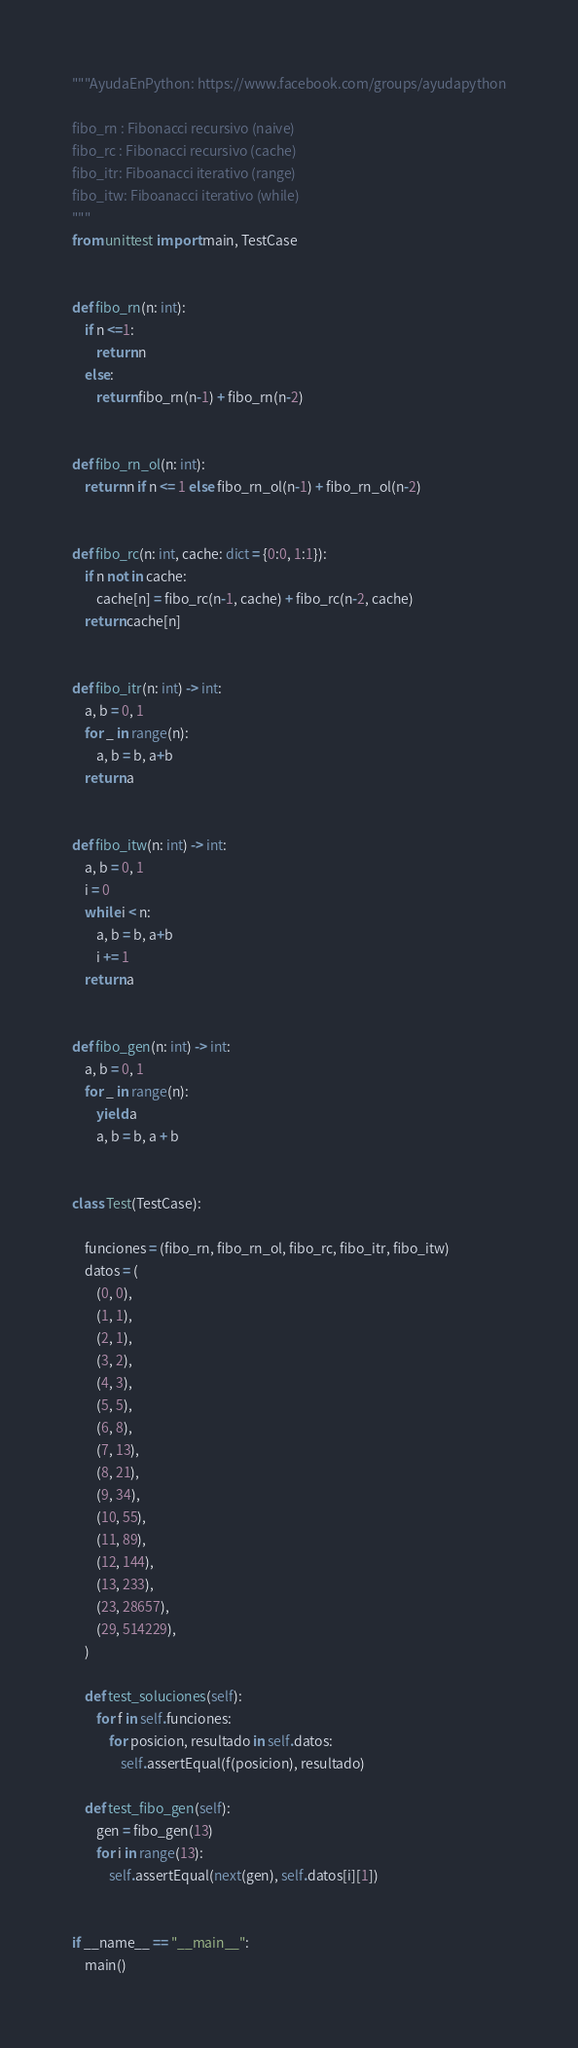<code> <loc_0><loc_0><loc_500><loc_500><_Python_>"""AyudaEnPython: https://www.facebook.com/groups/ayudapython

fibo_rn : Fibonacci recursivo (naive)
fibo_rc : Fibonacci recursivo (cache)
fibo_itr: Fiboanacci iterativo (range)
fibo_itw: Fiboanacci iterativo (while)
"""
from unittest import main, TestCase


def fibo_rn(n: int):
    if n <=1:
        return n
    else:
        return fibo_rn(n-1) + fibo_rn(n-2)


def fibo_rn_ol(n: int):
    return n if n <= 1 else fibo_rn_ol(n-1) + fibo_rn_ol(n-2)


def fibo_rc(n: int, cache: dict = {0:0, 1:1}):
    if n not in cache:
        cache[n] = fibo_rc(n-1, cache) + fibo_rc(n-2, cache)
    return cache[n]


def fibo_itr(n: int) -> int:
    a, b = 0, 1
    for _ in range(n):
        a, b = b, a+b
    return a


def fibo_itw(n: int) -> int:
    a, b = 0, 1
    i = 0
    while i < n:
        a, b = b, a+b
        i += 1
    return a


def fibo_gen(n: int) -> int:
    a, b = 0, 1
    for _ in range(n):
        yield a
        a, b = b, a + b


class Test(TestCase):
    
    funciones = (fibo_rn, fibo_rn_ol, fibo_rc, fibo_itr, fibo_itw)
    datos = (
        (0, 0),
        (1, 1),
        (2, 1),
        (3, 2),
        (4, 3),
        (5, 5),
        (6, 8),
        (7, 13),
        (8, 21),
        (9, 34),
        (10, 55),
        (11, 89),
        (12, 144),
        (13, 233),
        (23, 28657),
        (29, 514229),
    )

    def test_soluciones(self):
        for f in self.funciones:
            for posicion, resultado in self.datos:
                self.assertEqual(f(posicion), resultado)

    def test_fibo_gen(self):
        gen = fibo_gen(13)
        for i in range(13):
            self.assertEqual(next(gen), self.datos[i][1])


if __name__ == "__main__":
    main()
</code> 